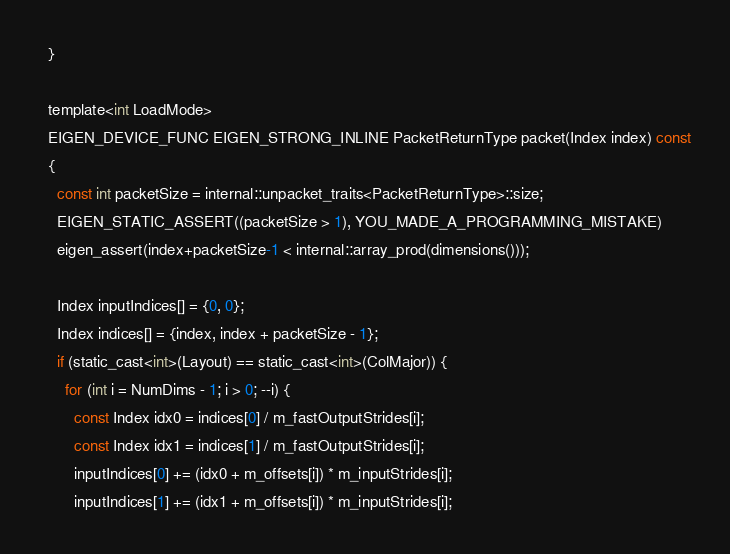<code> <loc_0><loc_0><loc_500><loc_500><_C_>  }

  template<int LoadMode>
  EIGEN_DEVICE_FUNC EIGEN_STRONG_INLINE PacketReturnType packet(Index index) const
  {
    const int packetSize = internal::unpacket_traits<PacketReturnType>::size;
    EIGEN_STATIC_ASSERT((packetSize > 1), YOU_MADE_A_PROGRAMMING_MISTAKE)
    eigen_assert(index+packetSize-1 < internal::array_prod(dimensions()));

    Index inputIndices[] = {0, 0};
    Index indices[] = {index, index + packetSize - 1};
    if (static_cast<int>(Layout) == static_cast<int>(ColMajor)) {
      for (int i = NumDims - 1; i > 0; --i) {
        const Index idx0 = indices[0] / m_fastOutputStrides[i];
        const Index idx1 = indices[1] / m_fastOutputStrides[i];
        inputIndices[0] += (idx0 + m_offsets[i]) * m_inputStrides[i];
        inputIndices[1] += (idx1 + m_offsets[i]) * m_inputStrides[i];</code> 